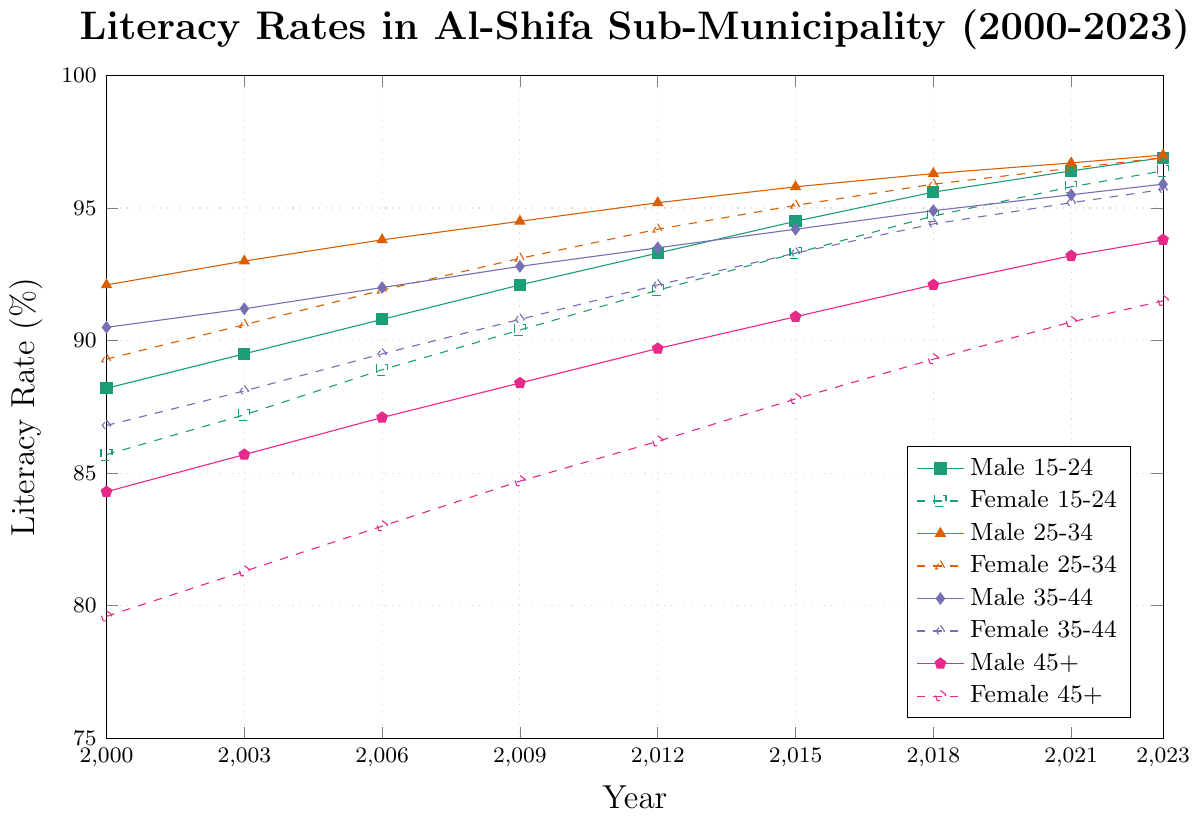What is the literacy rate for Female 35-44 in 2023? In 2023, the line representing Female 35-44 intersects at the point which corresponds to a literacy rate of 95.7% on the y-axis.
Answer: 95.7% Which age group showed the highest literacy rate for males in 2023? By checking the highest point of each male-related line in 2023, we can observe that the Male 25-34 age group peaked the highest at 97.0%.
Answer: Male 25-34 What is the difference in literacy rate between Female 25-34 and Female 45+ in 2021? In 2021, Female 25-34 literacy rate is 96.5% and Female 45+ literacy rate is 90.7%. Calculating the difference: 96.5% - 90.7% = 5.8%.
Answer: 5.8% On average, how much did the literacy rate for Male 15-24 increase per year from 2000 to 2023? The literacy rate for Male 15-24 went from 88.2% in 2000 to 96.9% in 2023, giving an increase of 96.9% - 88.2% = 8.7%. This spans 23 years, so the average annual increase is 8.7% / 23 = 0.378%.
Answer: 0.378% Which female age group experienced the fastest growth in literacy rates from 2000 to 2023? Calculating the increase: Female 15-24 from 85.7% to 96.4% (+10.7%), Female 25-34 from 89.3% to 96.9% (+7.6%), Female 35-44 from 86.8% to 95.7% (+8.9%), Female 45+ from 79.6% to 91.5% (+11.9%). Comparing these, Female 45+ had the highest increase of 11.9%.
Answer: Female 45+ By how much did the literacy rate for Male 45+ increase between 2000 and 2023? From the figure, in 2000, the rate was 84.3% and in 2023 it increased to 93.8%. The increase is 93.8% - 84.3% = 9.5%.
Answer: 9.5% Is the literacy rate of Female 25-34 in 2023 higher than Male 35-44 in 2018? The Female 25-34 rate in 2023 is 96.9%, while the Male 35-44 rate in 2018 is 94.9%. Since 96.9% is greater than 94.9%, the Female 25-34 rate in 2023 is higher.
Answer: Yes Which group showed a more significant increase in their literacy rate from 2000 to 2023: Male 45+ or Female 15-24? For Male 45+, the increase is from 84.3% to 93.8% (a 9.5% increase). For Female 15-24, the increase is from 85.7% to 96.4% (a 10.7% increase). Since 10.7% > 9.5%, Female 15-24 showed a more significant increase.
Answer: Female 15-24 